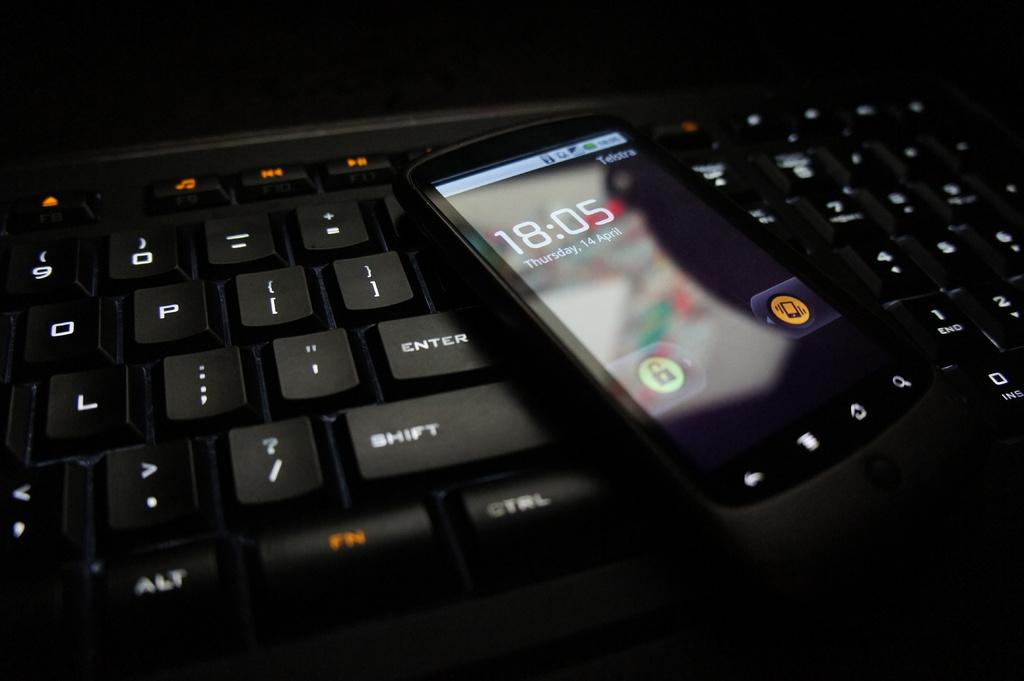<image>
Present a compact description of the photo's key features. A smart device reading 18:05 on top of a keyboard. 